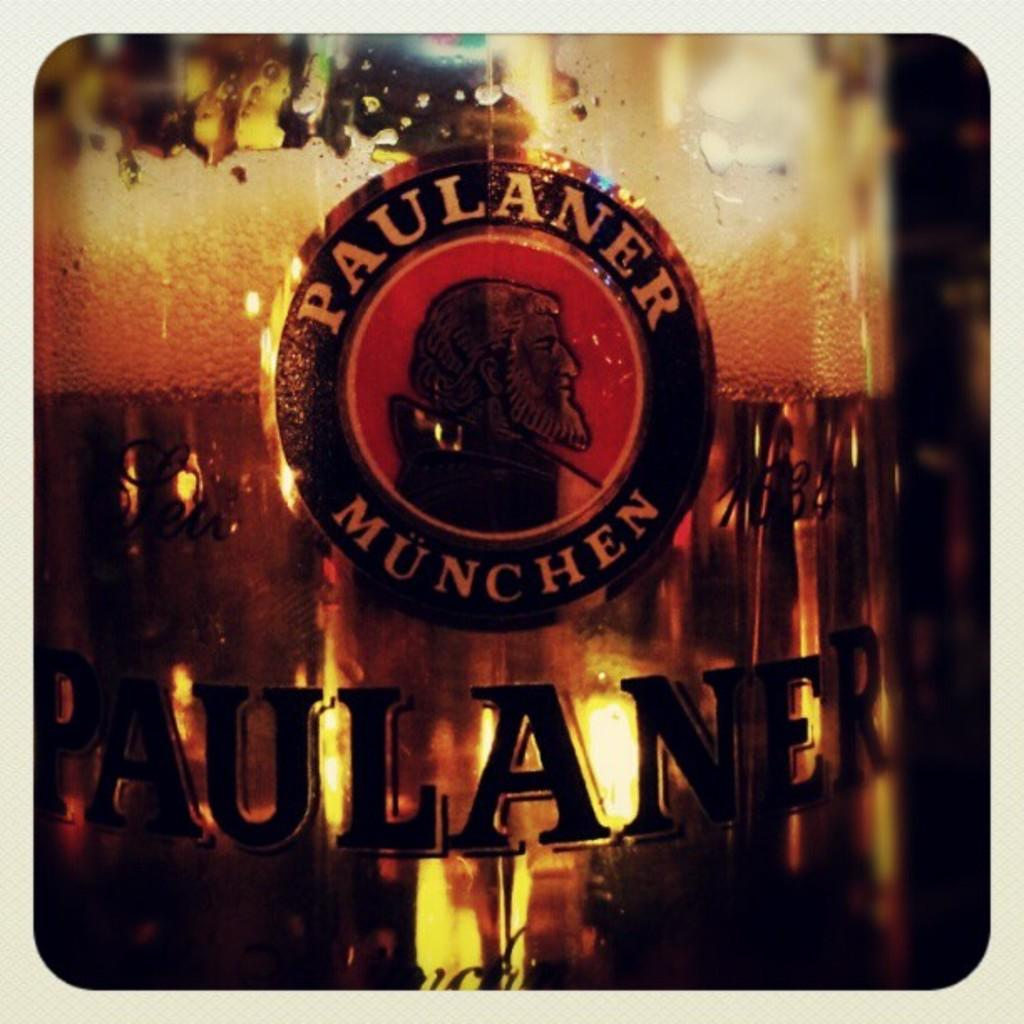What object is present in the image that is typically used for drinking? There is a glass in the image. What is inside the glass that is visible in the image? The glass is filled with beer. What type of pest can be seen crawling on the rim of the glass in the image? There are no pests visible in the image, and therefore no such activity can be observed. 